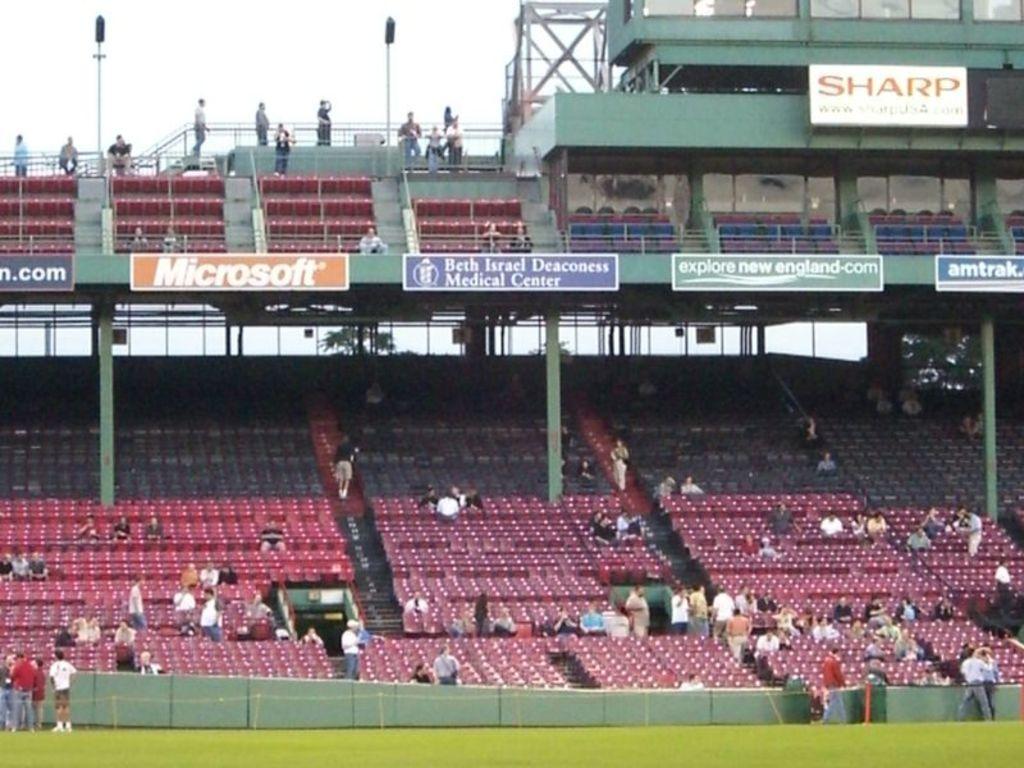Which company's ad is displayed on the orange sign?
Keep it short and to the point. Microsoft. 